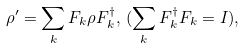Convert formula to latex. <formula><loc_0><loc_0><loc_500><loc_500>\rho ^ { \prime } = \sum _ { k } F _ { k } \rho F _ { k } ^ { \dagger } , \, ( \sum _ { k } F _ { k } ^ { \dagger } F _ { k } = I ) ,</formula> 